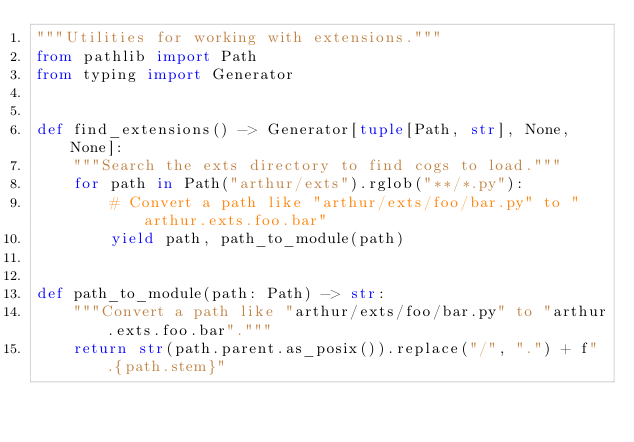Convert code to text. <code><loc_0><loc_0><loc_500><loc_500><_Python_>"""Utilities for working with extensions."""
from pathlib import Path
from typing import Generator


def find_extensions() -> Generator[tuple[Path, str], None, None]:
    """Search the exts directory to find cogs to load."""
    for path in Path("arthur/exts").rglob("**/*.py"):
        # Convert a path like "arthur/exts/foo/bar.py" to "arthur.exts.foo.bar"
        yield path, path_to_module(path)


def path_to_module(path: Path) -> str:
    """Convert a path like "arthur/exts/foo/bar.py" to "arthur.exts.foo.bar"."""
    return str(path.parent.as_posix()).replace("/", ".") + f".{path.stem}"
</code> 